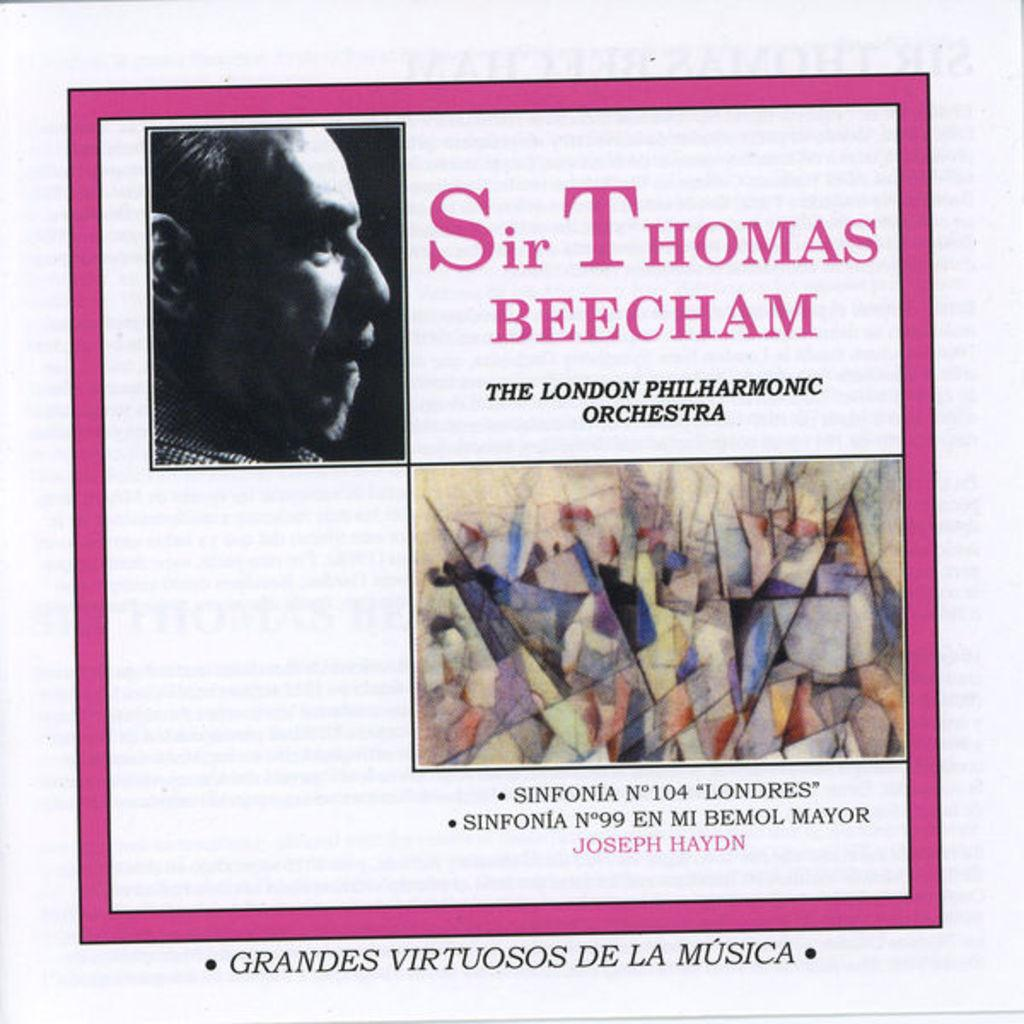What is featured on the poster in the image? The poster contains a picture of a man. Where is the text located on the poster? The text is on the right side of the poster. What color is the border of the poster? The poster border is pink. What type of toothpaste is being advertised on the poster? There is no toothpaste or advertisement present on the poster; it features a picture of a man and text. 